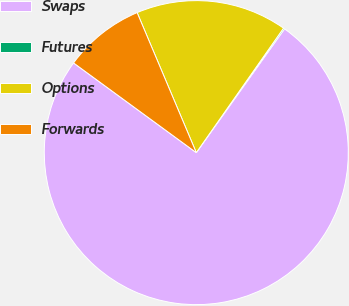Convert chart to OTSL. <chart><loc_0><loc_0><loc_500><loc_500><pie_chart><fcel>Swaps<fcel>Futures<fcel>Options<fcel>Forwards<nl><fcel>75.18%<fcel>0.13%<fcel>16.09%<fcel>8.59%<nl></chart> 